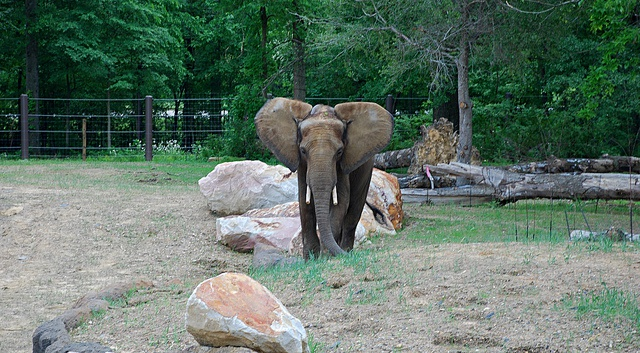Describe the objects in this image and their specific colors. I can see a elephant in darkgreen, gray, black, and darkgray tones in this image. 